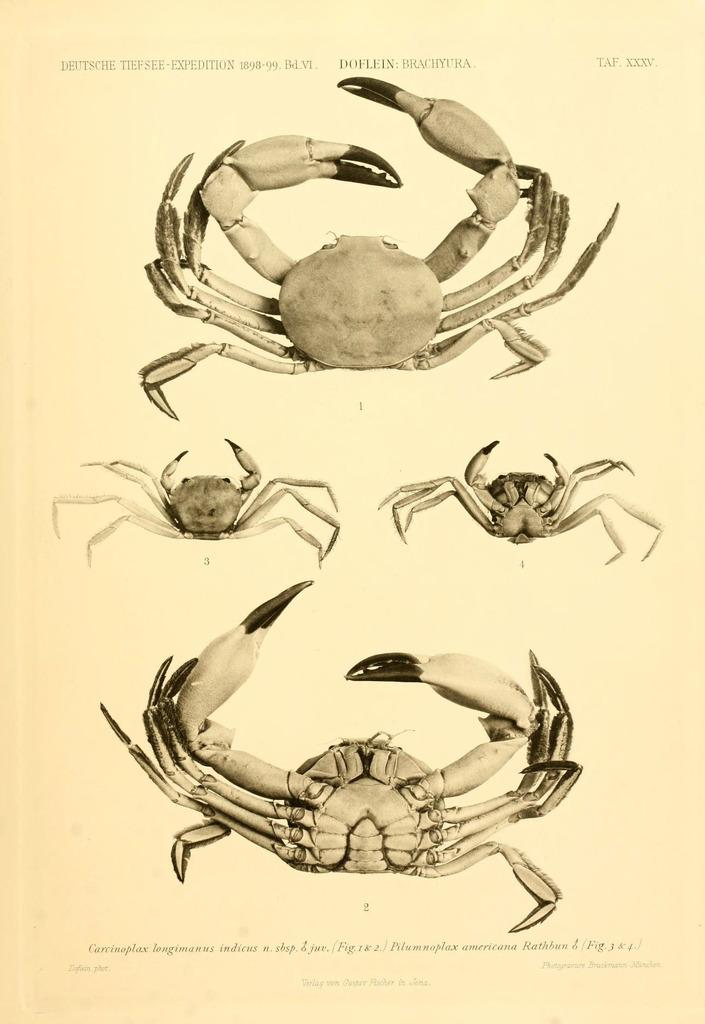What is present on the paper in the image? The paper contains images of crabs. Is there any text on the paper? Yes, there is text on the paper. How many moms are present in the image? There is no mention of a mom or any people in the image; it only features a paper with images of crabs and text. 